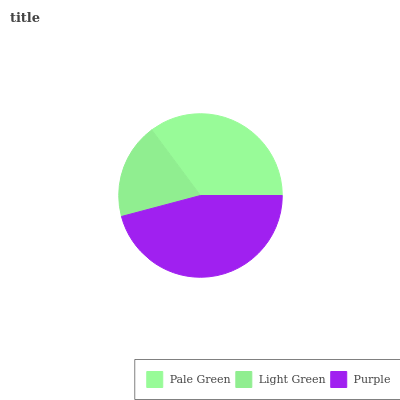Is Light Green the minimum?
Answer yes or no. Yes. Is Purple the maximum?
Answer yes or no. Yes. Is Purple the minimum?
Answer yes or no. No. Is Light Green the maximum?
Answer yes or no. No. Is Purple greater than Light Green?
Answer yes or no. Yes. Is Light Green less than Purple?
Answer yes or no. Yes. Is Light Green greater than Purple?
Answer yes or no. No. Is Purple less than Light Green?
Answer yes or no. No. Is Pale Green the high median?
Answer yes or no. Yes. Is Pale Green the low median?
Answer yes or no. Yes. Is Purple the high median?
Answer yes or no. No. Is Light Green the low median?
Answer yes or no. No. 